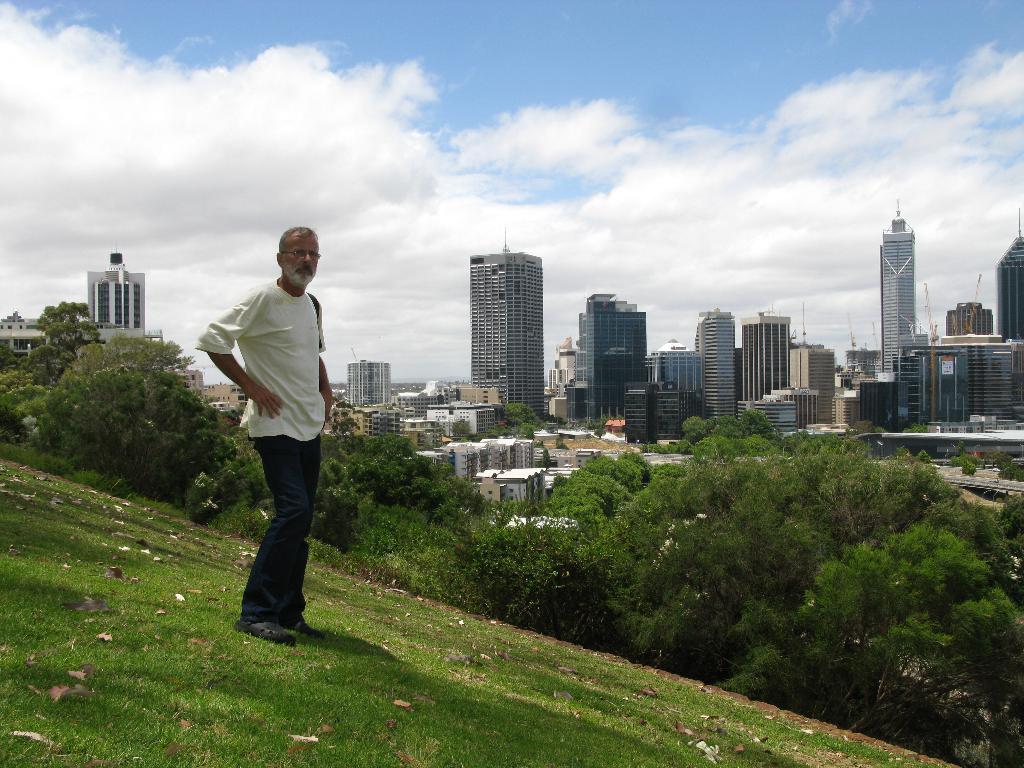Describe this image in one or two sentences. This picture is taken from outside of the city. In this image, on the left side, we can see a man wearing a white color shirt is standing on the grass. On the right side, we can see some trees, plants, building, towers. On the left side, we can see some plants, trees, building. At the top, we can see a sky, at the bottom, we can see a grass. 